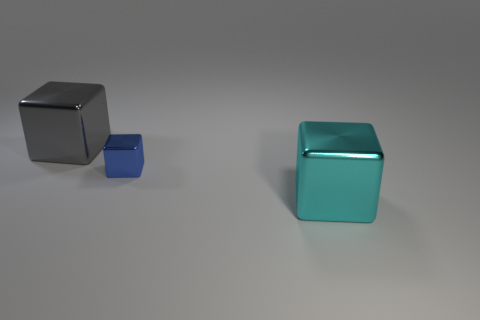Is there any other thing that has the same size as the blue metallic cube?
Ensure brevity in your answer.  No. The small block has what color?
Make the answer very short. Blue. There is a big gray shiny thing; are there any gray metallic things in front of it?
Provide a succinct answer. No. What color is the large shiny block that is behind the large cube that is in front of the shiny cube that is to the left of the blue cube?
Offer a terse response. Gray. What number of things are behind the blue thing and right of the blue cube?
Give a very brief answer. 0. How many spheres are either tiny blue metal things or small red objects?
Ensure brevity in your answer.  0. Are there any large green rubber spheres?
Make the answer very short. No. How many other objects are the same material as the big cyan object?
Give a very brief answer. 2. There is a gray thing that is the same size as the cyan block; what is it made of?
Ensure brevity in your answer.  Metal. Does the large thing behind the tiny blue cube have the same shape as the blue shiny thing?
Offer a terse response. Yes. 